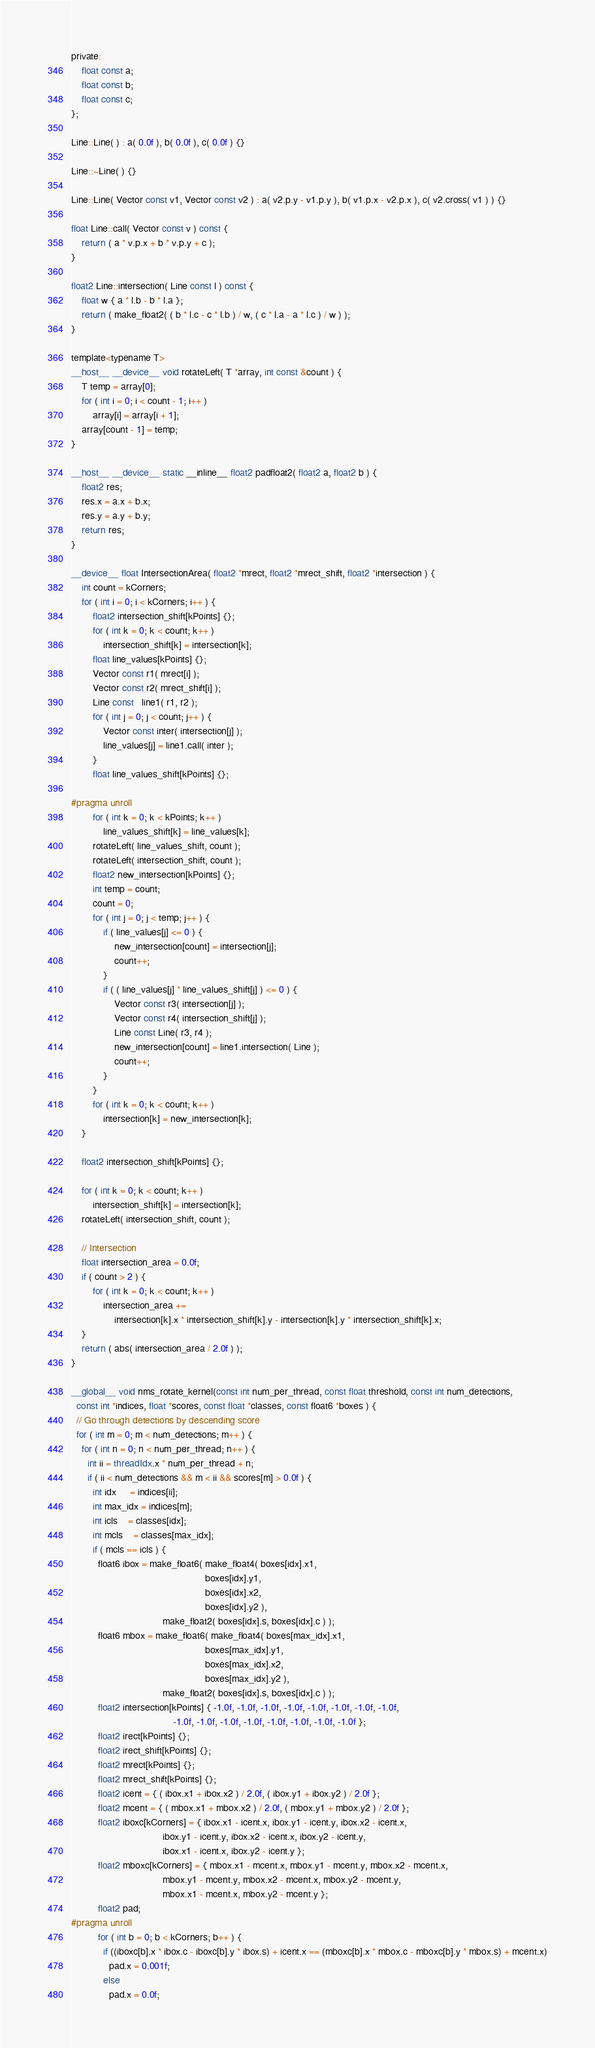<code> <loc_0><loc_0><loc_500><loc_500><_Cuda_>
private:
    float const a;
    float const b;
    float const c;
};

Line::Line( ) : a( 0.0f ), b( 0.0f ), c( 0.0f ) {}

Line::~Line( ) {}

Line::Line( Vector const v1, Vector const v2 ) : a( v2.p.y - v1.p.y ), b( v1.p.x - v2.p.x ), c( v2.cross( v1 ) ) {}

float Line::call( Vector const v ) const {
    return ( a * v.p.x + b * v.p.y + c );
}

float2 Line::intersection( Line const l ) const {
    float w { a * l.b - b * l.a };
    return ( make_float2( ( b * l.c - c * l.b ) / w, ( c * l.a - a * l.c ) / w ) );
}

template<typename T>
__host__ __device__ void rotateLeft( T *array, int const &count ) {
    T temp = array[0];
    for ( int i = 0; i < count - 1; i++ )
        array[i] = array[i + 1];
    array[count - 1] = temp;
}

__host__ __device__ static __inline__ float2 padfloat2( float2 a, float2 b ) {
    float2 res;
    res.x = a.x + b.x;
    res.y = a.y + b.y;
    return res;
}

__device__ float IntersectionArea( float2 *mrect, float2 *mrect_shift, float2 *intersection ) {
    int count = kCorners;
    for ( int i = 0; i < kCorners; i++ ) {
        float2 intersection_shift[kPoints] {};
        for ( int k = 0; k < count; k++ )
            intersection_shift[k] = intersection[k];
        float line_values[kPoints] {};
        Vector const r1( mrect[i] );
        Vector const r2( mrect_shift[i] );
        Line const   line1( r1, r2 );
        for ( int j = 0; j < count; j++ ) {
            Vector const inter( intersection[j] );
            line_values[j] = line1.call( inter );
        }
        float line_values_shift[kPoints] {};

#pragma unroll
        for ( int k = 0; k < kPoints; k++ )
            line_values_shift[k] = line_values[k];
        rotateLeft( line_values_shift, count );
        rotateLeft( intersection_shift, count );
        float2 new_intersection[kPoints] {};
        int temp = count;
        count = 0;
        for ( int j = 0; j < temp; j++ ) {
            if ( line_values[j] <= 0 ) {
                new_intersection[count] = intersection[j];
                count++;
            }
            if ( ( line_values[j] * line_values_shift[j] ) <= 0 ) {
                Vector const r3( intersection[j] );
                Vector const r4( intersection_shift[j] );
                Line const Line( r3, r4 );
                new_intersection[count] = line1.intersection( Line );
                count++;
            }
        }
        for ( int k = 0; k < count; k++ )
            intersection[k] = new_intersection[k];
    }

    float2 intersection_shift[kPoints] {};

    for ( int k = 0; k < count; k++ )
        intersection_shift[k] = intersection[k];
    rotateLeft( intersection_shift, count );

    // Intersection
    float intersection_area = 0.0f;
    if ( count > 2 ) {
        for ( int k = 0; k < count; k++ )
            intersection_area +=
                intersection[k].x * intersection_shift[k].y - intersection[k].y * intersection_shift[k].x;
    }
    return ( abs( intersection_area / 2.0f ) );
}

__global__ void nms_rotate_kernel(const int num_per_thread, const float threshold, const int num_detections, 
  const int *indices, float *scores, const float *classes, const float6 *boxes ) {
  // Go through detections by descending score
  for ( int m = 0; m < num_detections; m++ ) {
    for ( int n = 0; n < num_per_thread; n++ ) {
      int ii = threadIdx.x * num_per_thread + n;
      if ( ii < num_detections && m < ii && scores[m] > 0.0f ) {
        int idx     = indices[ii];
        int max_idx = indices[m];
        int icls    = classes[idx];
        int mcls    = classes[max_idx];
        if ( mcls == icls ) {
          float6 ibox = make_float6( make_float4( boxes[idx].x1,
                                                  boxes[idx].y1,
                                                  boxes[idx].x2,
                                                  boxes[idx].y2 ),
                                  make_float2( boxes[idx].s, boxes[idx].c ) );
          float6 mbox = make_float6( make_float4( boxes[max_idx].x1,
                                                  boxes[max_idx].y1,
                                                  boxes[max_idx].x2,
                                                  boxes[max_idx].y2 ),
                                  make_float2( boxes[idx].s, boxes[idx].c ) );
          float2 intersection[kPoints] { -1.0f, -1.0f, -1.0f, -1.0f, -1.0f, -1.0f, -1.0f, -1.0f,
                                      -1.0f, -1.0f, -1.0f, -1.0f, -1.0f, -1.0f, -1.0f, -1.0f };
          float2 irect[kPoints] {};
          float2 irect_shift[kPoints] {};
          float2 mrect[kPoints] {};
          float2 mrect_shift[kPoints] {};
          float2 icent = { ( ibox.x1 + ibox.x2 ) / 2.0f, ( ibox.y1 + ibox.y2 ) / 2.0f };
          float2 mcent = { ( mbox.x1 + mbox.x2 ) / 2.0f, ( mbox.y1 + mbox.y2 ) / 2.0f };
          float2 iboxc[kCorners] = { ibox.x1 - icent.x, ibox.y1 - icent.y, ibox.x2 - icent.x,
                                  ibox.y1 - icent.y, ibox.x2 - icent.x, ibox.y2 - icent.y,
                                  ibox.x1 - icent.x, ibox.y2 - icent.y };
          float2 mboxc[kCorners] = { mbox.x1 - mcent.x, mbox.y1 - mcent.y, mbox.x2 - mcent.x,
                                  mbox.y1 - mcent.y, mbox.x2 - mcent.x, mbox.y2 - mcent.y,
                                  mbox.x1 - mcent.x, mbox.y2 - mcent.y };
          float2 pad;
#pragma unroll
          for ( int b = 0; b < kCorners; b++ ) {
            if ((iboxc[b].x * ibox.c - iboxc[b].y * ibox.s) + icent.x == (mboxc[b].x * mbox.c - mboxc[b].y * mbox.s) + mcent.x)
              pad.x = 0.001f;
            else
              pad.x = 0.0f;</code> 